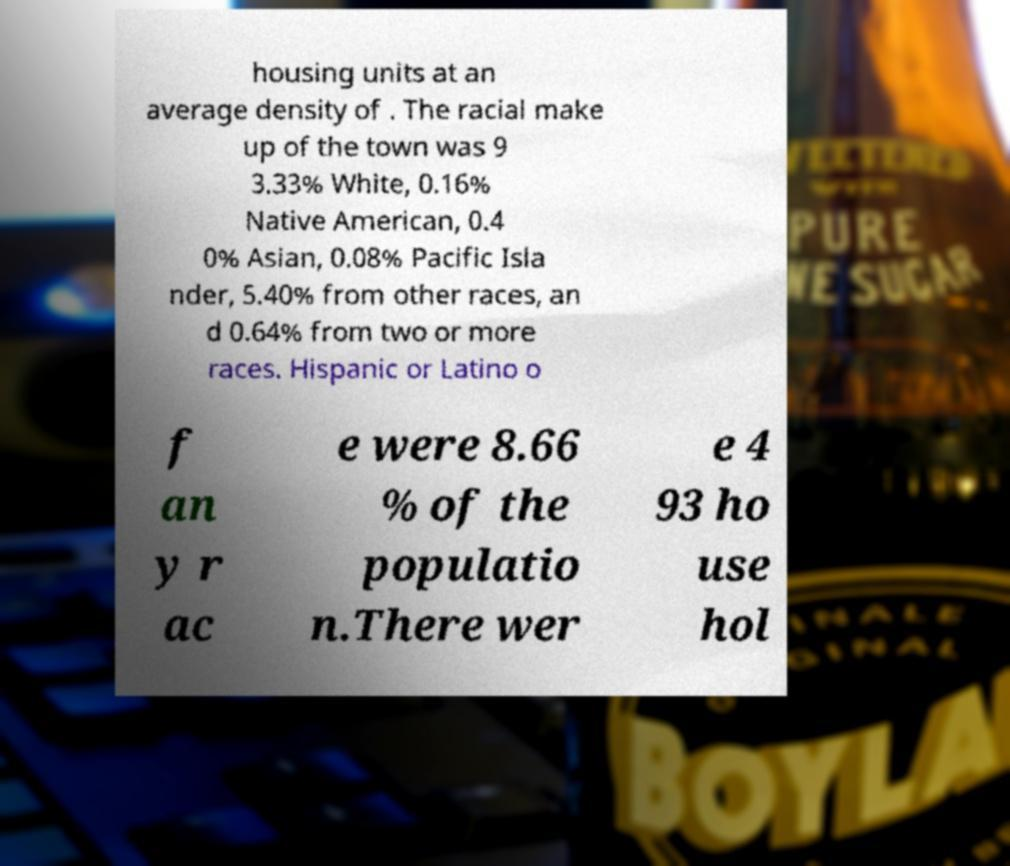Could you assist in decoding the text presented in this image and type it out clearly? housing units at an average density of . The racial make up of the town was 9 3.33% White, 0.16% Native American, 0.4 0% Asian, 0.08% Pacific Isla nder, 5.40% from other races, an d 0.64% from two or more races. Hispanic or Latino o f an y r ac e were 8.66 % of the populatio n.There wer e 4 93 ho use hol 